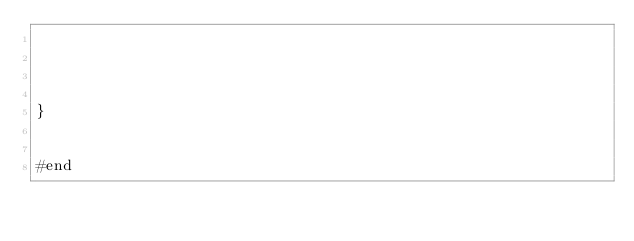<code> <loc_0><loc_0><loc_500><loc_500><_Haxe_>



}


#end</code> 